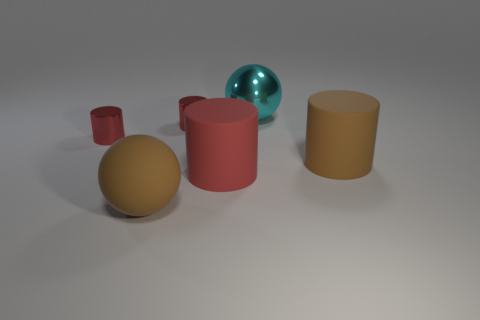Subtract all brown rubber cylinders. How many cylinders are left? 3 Add 3 metal balls. How many objects exist? 9 Subtract 2 spheres. How many spheres are left? 0 Subtract all brown cylinders. How many cylinders are left? 3 Subtract all balls. How many objects are left? 4 Add 5 large matte spheres. How many large matte spheres exist? 6 Subtract 0 brown cubes. How many objects are left? 6 Subtract all green cylinders. Subtract all green cubes. How many cylinders are left? 4 Subtract all blue blocks. How many red cylinders are left? 3 Subtract all big brown cubes. Subtract all big brown matte objects. How many objects are left? 4 